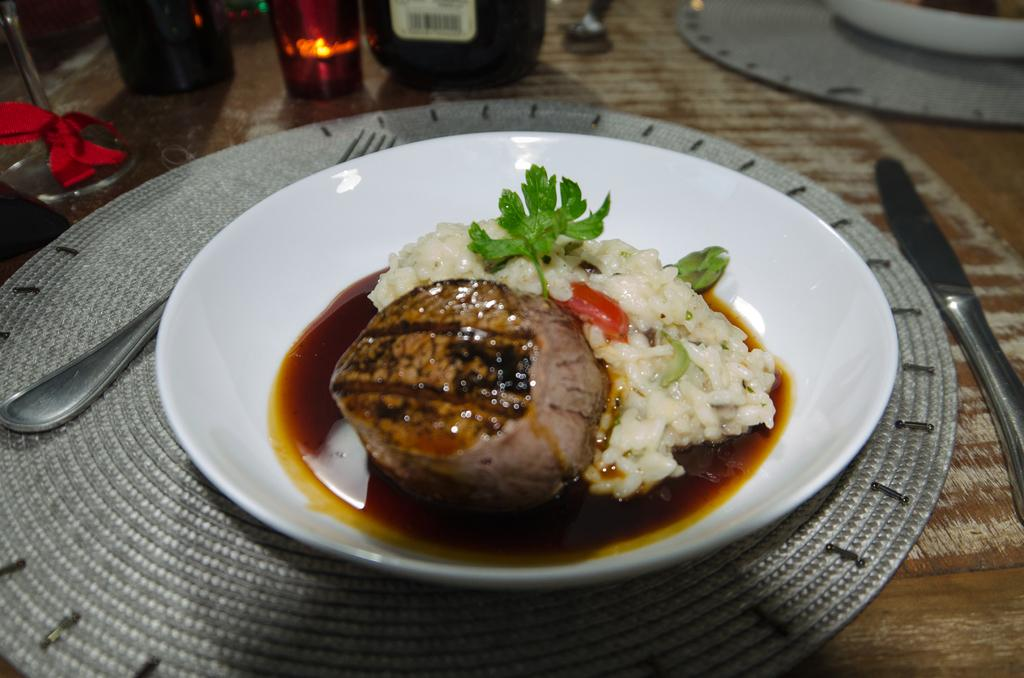What type of dishware is used for the food in the image? The food is in a white color bowl in the image. What utensils are visible in the image? There are spoons visible in the image. What type of containers can be seen in the image? There are bottles in the image. What is the color of the surface on which the objects are placed? The objects are on a brown color surface in the image. What type of bushes can be seen growing near the food in the image? There are no bushes present in the image; it only shows food in a bowl, spoons, bottles, and objects on a brown surface. 